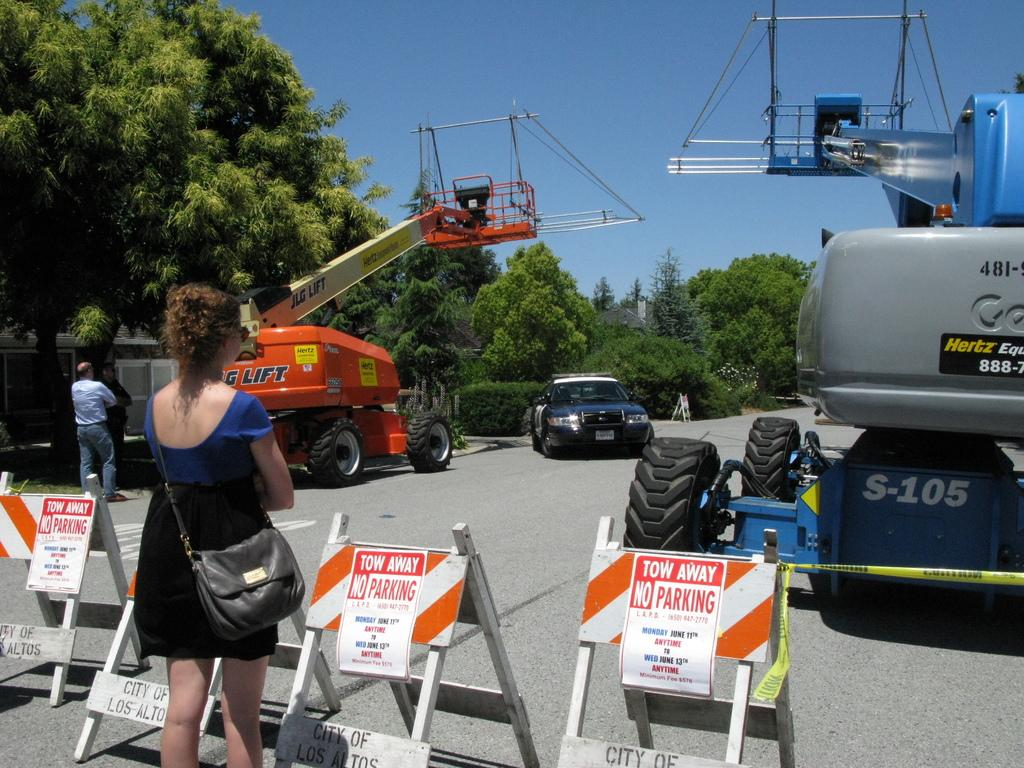What type of large birds are in the image? There are two cranes in the image. What other object can be seen in the image? There is a car in the image. Who is present in the image? There is a woman standing in the image. What type of vegetation is visible in the image? There are trees around the scene. What type of chess piece is the woman holding in the image? There is no chess piece or any indication of a game of chess in the image. How many feet are visible in the image? The number of feet visible in the image cannot be determined from the provided facts. 